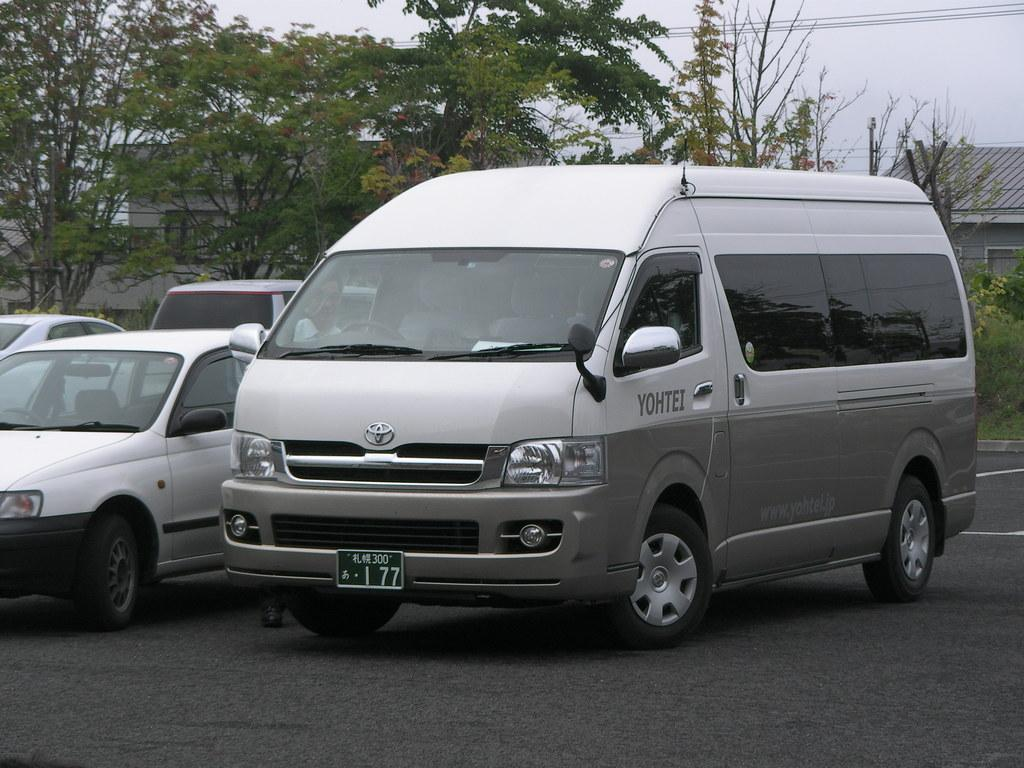<image>
Provide a brief description of the given image. A white and gray van is parked with YOHTEI on the driver's side door. 